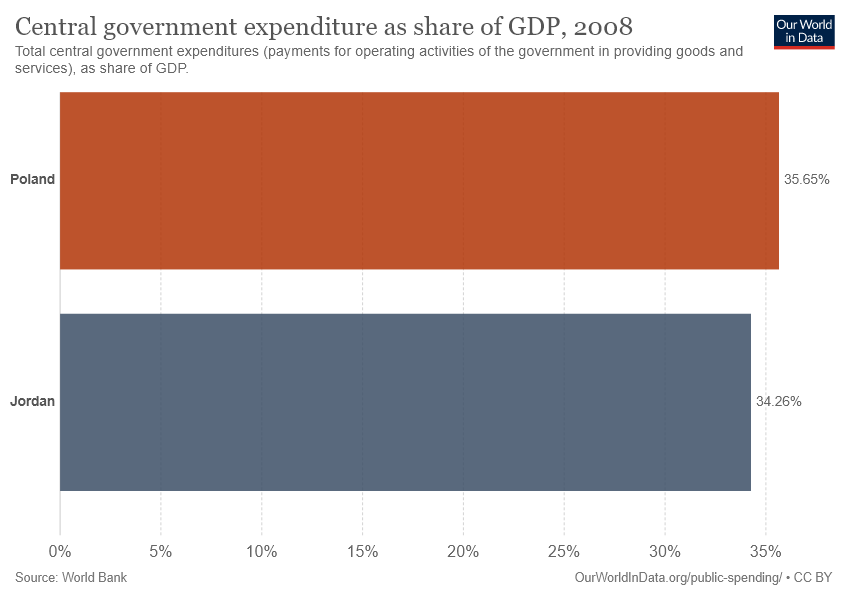Can we infer anything about the economic scale or overall budget from this graph alone? This graph only shows the percentage of government expenditure relative to GDP, not the actual size or scale of the budgets. Higher percentages indicate more spending relative to the size of the economy, but without raw budget figures or total GDP values, we cannot determine the overall economic scale or total budget. 